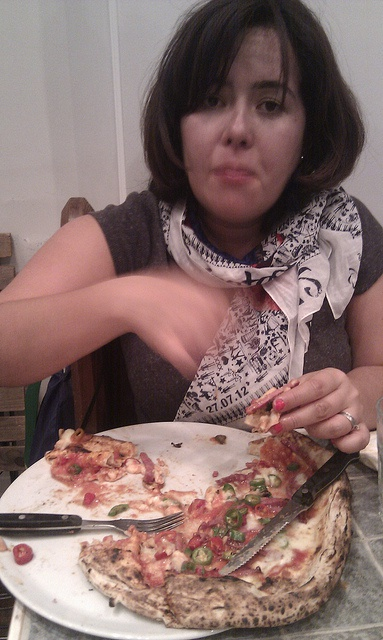Describe the objects in this image and their specific colors. I can see people in darkgray, black, brown, and lightpink tones, pizza in darkgray, brown, and tan tones, handbag in darkgray, black, maroon, and brown tones, fork in darkgray, black, and gray tones, and knife in darkgray, black, gray, and maroon tones in this image. 